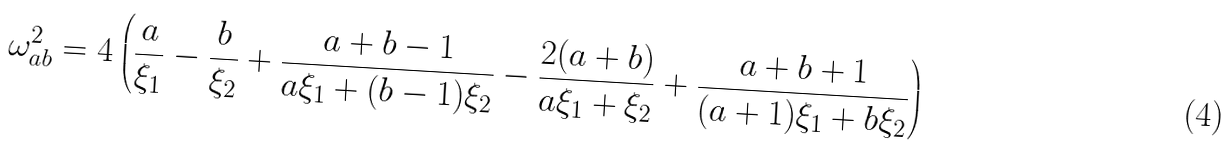<formula> <loc_0><loc_0><loc_500><loc_500>\omega ^ { 2 } _ { a b } = 4 \left ( \frac { a } { \xi _ { 1 } } - \frac { b } { \xi _ { 2 } } + \frac { a + b - 1 } { a \xi _ { 1 } + ( b - 1 ) \xi _ { 2 } } - \frac { 2 ( a + b ) } { a \xi _ { 1 } + \xi _ { 2 } } + \frac { a + b + 1 } { ( a + 1 ) \xi _ { 1 } + b \xi _ { 2 } } \right )</formula> 